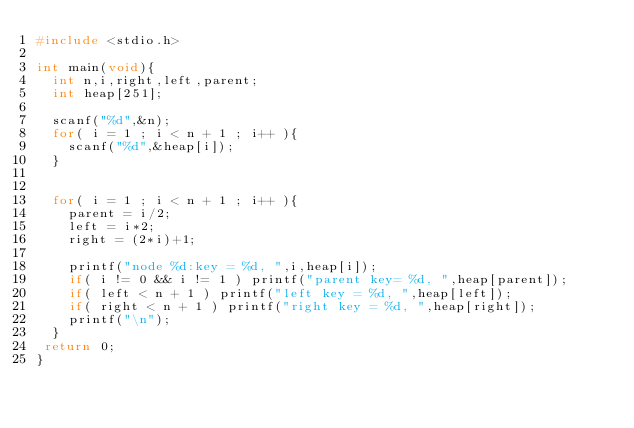<code> <loc_0><loc_0><loc_500><loc_500><_C_>#include <stdio.h>

int main(void){
  int n,i,right,left,parent;
  int heap[251];

  scanf("%d",&n);
  for( i = 1 ; i < n + 1 ; i++ ){
    scanf("%d",&heap[i]);
  }


  for( i = 1 ; i < n + 1 ; i++ ){
    parent = i/2;
    left = i*2;
    right = (2*i)+1;

    printf("node %d:key = %d, ",i,heap[i]);
    if( i != 0 && i != 1 ) printf("parent key= %d, ",heap[parent]);
    if( left < n + 1 ) printf("left key = %d, ",heap[left]);
    if( right < n + 1 ) printf("right key = %d, ",heap[right]);
    printf("\n");
  }
 return 0;
}</code> 